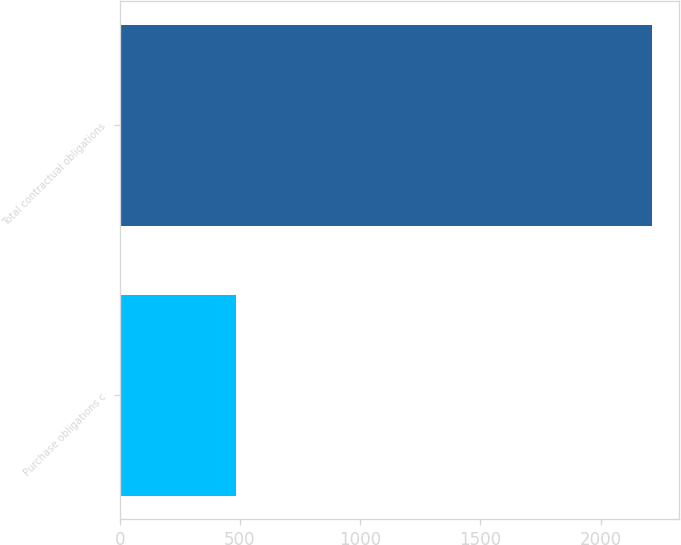Convert chart to OTSL. <chart><loc_0><loc_0><loc_500><loc_500><bar_chart><fcel>Purchase obligations c<fcel>Total contractual obligations<nl><fcel>484<fcel>2214<nl></chart> 